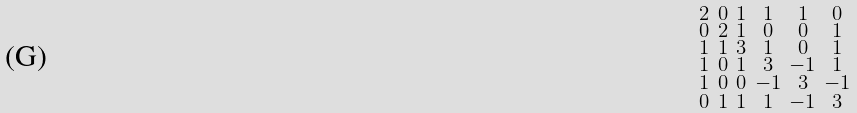<formula> <loc_0><loc_0><loc_500><loc_500>\begin{smallmatrix} 2 & 0 & 1 & 1 & 1 & 0 \\ 0 & 2 & 1 & 0 & 0 & 1 \\ 1 & 1 & 3 & 1 & 0 & 1 \\ 1 & 0 & 1 & 3 & - 1 & 1 \\ 1 & 0 & 0 & - 1 & 3 & - 1 \\ 0 & 1 & 1 & 1 & - 1 & 3 \end{smallmatrix}</formula> 